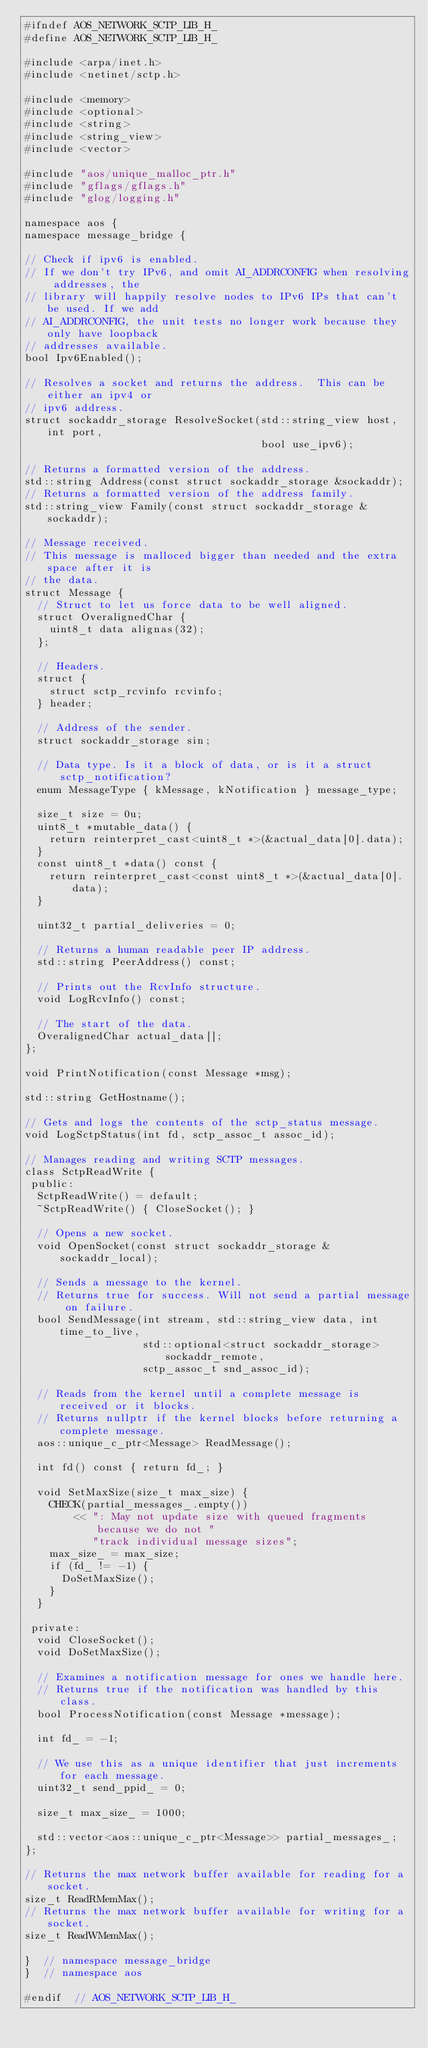Convert code to text. <code><loc_0><loc_0><loc_500><loc_500><_C_>#ifndef AOS_NETWORK_SCTP_LIB_H_
#define AOS_NETWORK_SCTP_LIB_H_

#include <arpa/inet.h>
#include <netinet/sctp.h>

#include <memory>
#include <optional>
#include <string>
#include <string_view>
#include <vector>

#include "aos/unique_malloc_ptr.h"
#include "gflags/gflags.h"
#include "glog/logging.h"

namespace aos {
namespace message_bridge {

// Check if ipv6 is enabled.
// If we don't try IPv6, and omit AI_ADDRCONFIG when resolving addresses, the
// library will happily resolve nodes to IPv6 IPs that can't be used. If we add
// AI_ADDRCONFIG, the unit tests no longer work because they only have loopback
// addresses available.
bool Ipv6Enabled();

// Resolves a socket and returns the address.  This can be either an ipv4 or
// ipv6 address.
struct sockaddr_storage ResolveSocket(std::string_view host, int port,
                                      bool use_ipv6);

// Returns a formatted version of the address.
std::string Address(const struct sockaddr_storage &sockaddr);
// Returns a formatted version of the address family.
std::string_view Family(const struct sockaddr_storage &sockaddr);

// Message received.
// This message is malloced bigger than needed and the extra space after it is
// the data.
struct Message {
  // Struct to let us force data to be well aligned.
  struct OveralignedChar {
    uint8_t data alignas(32);
  };

  // Headers.
  struct {
    struct sctp_rcvinfo rcvinfo;
  } header;

  // Address of the sender.
  struct sockaddr_storage sin;

  // Data type. Is it a block of data, or is it a struct sctp_notification?
  enum MessageType { kMessage, kNotification } message_type;

  size_t size = 0u;
  uint8_t *mutable_data() {
    return reinterpret_cast<uint8_t *>(&actual_data[0].data);
  }
  const uint8_t *data() const {
    return reinterpret_cast<const uint8_t *>(&actual_data[0].data);
  }

  uint32_t partial_deliveries = 0;

  // Returns a human readable peer IP address.
  std::string PeerAddress() const;

  // Prints out the RcvInfo structure.
  void LogRcvInfo() const;

  // The start of the data.
  OveralignedChar actual_data[];
};

void PrintNotification(const Message *msg);

std::string GetHostname();

// Gets and logs the contents of the sctp_status message.
void LogSctpStatus(int fd, sctp_assoc_t assoc_id);

// Manages reading and writing SCTP messages.
class SctpReadWrite {
 public:
  SctpReadWrite() = default;
  ~SctpReadWrite() { CloseSocket(); }

  // Opens a new socket.
  void OpenSocket(const struct sockaddr_storage &sockaddr_local);

  // Sends a message to the kernel.
  // Returns true for success. Will not send a partial message on failure.
  bool SendMessage(int stream, std::string_view data, int time_to_live,
                   std::optional<struct sockaddr_storage> sockaddr_remote,
                   sctp_assoc_t snd_assoc_id);

  // Reads from the kernel until a complete message is received or it blocks.
  // Returns nullptr if the kernel blocks before returning a complete message.
  aos::unique_c_ptr<Message> ReadMessage();

  int fd() const { return fd_; }

  void SetMaxSize(size_t max_size) {
    CHECK(partial_messages_.empty())
        << ": May not update size with queued fragments because we do not "
           "track individual message sizes";
    max_size_ = max_size;
    if (fd_ != -1) {
      DoSetMaxSize();
    }
  }

 private:
  void CloseSocket();
  void DoSetMaxSize();

  // Examines a notification message for ones we handle here.
  // Returns true if the notification was handled by this class.
  bool ProcessNotification(const Message *message);

  int fd_ = -1;

  // We use this as a unique identifier that just increments for each message.
  uint32_t send_ppid_ = 0;

  size_t max_size_ = 1000;

  std::vector<aos::unique_c_ptr<Message>> partial_messages_;
};

// Returns the max network buffer available for reading for a socket.
size_t ReadRMemMax();
// Returns the max network buffer available for writing for a socket.
size_t ReadWMemMax();

}  // namespace message_bridge
}  // namespace aos

#endif  // AOS_NETWORK_SCTP_LIB_H_
</code> 